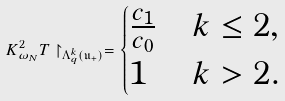<formula> <loc_0><loc_0><loc_500><loc_500>K _ { \omega _ { N } } ^ { 2 } T \restriction _ { \Lambda _ { q } ^ { k } ( \mathfrak { u } _ { + } ) } = \begin{cases} \frac { c _ { 1 } } { c _ { 0 } } & k \leq 2 , \\ 1 & k > 2 . \end{cases}</formula> 